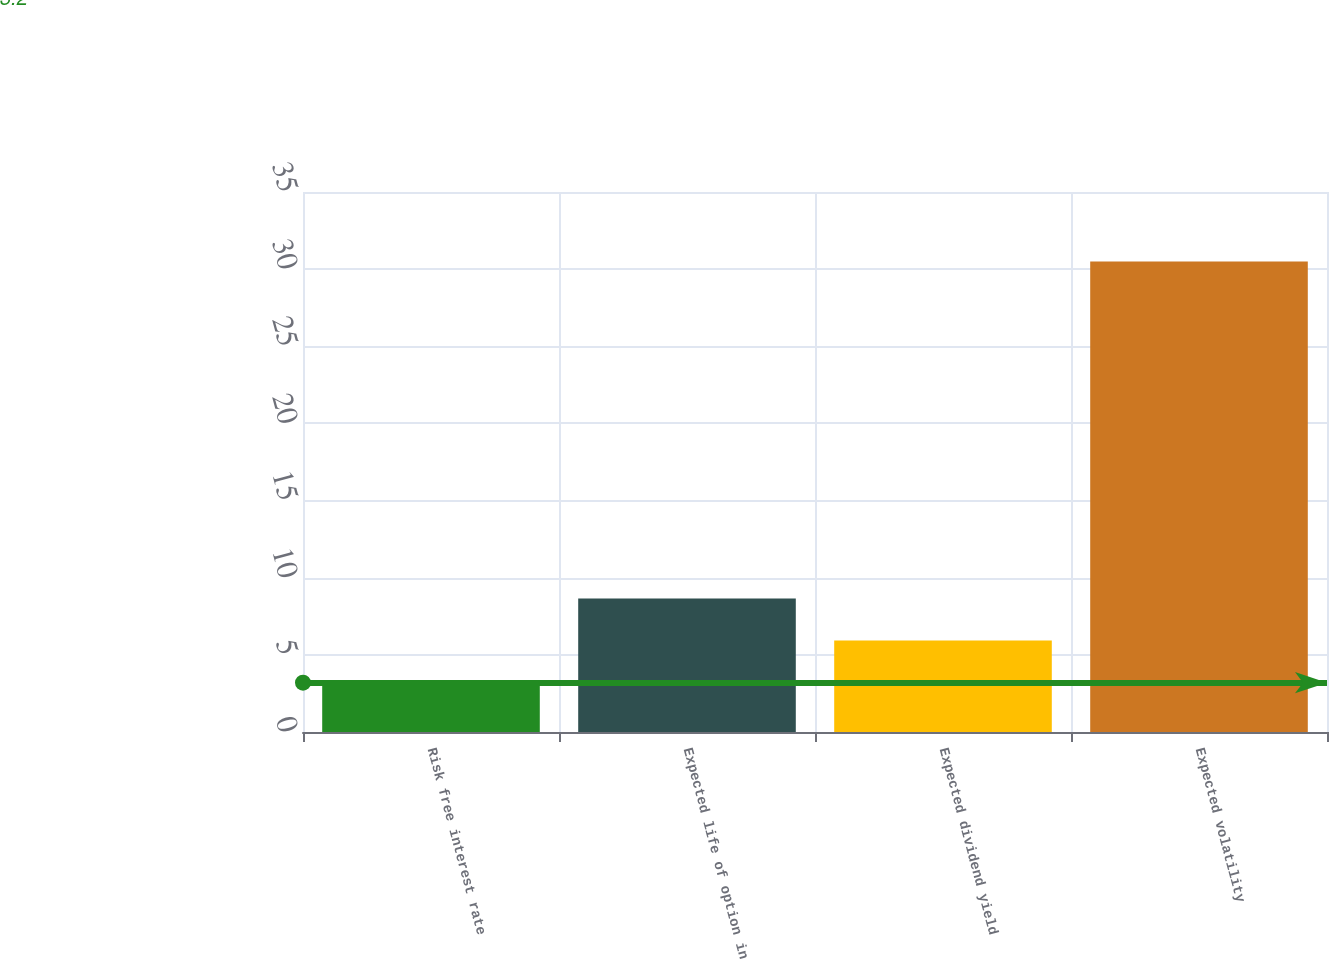Convert chart. <chart><loc_0><loc_0><loc_500><loc_500><bar_chart><fcel>Risk free interest rate<fcel>Expected life of option in<fcel>Expected dividend yield<fcel>Expected volatility<nl><fcel>3.2<fcel>8.66<fcel>5.93<fcel>30.5<nl></chart> 